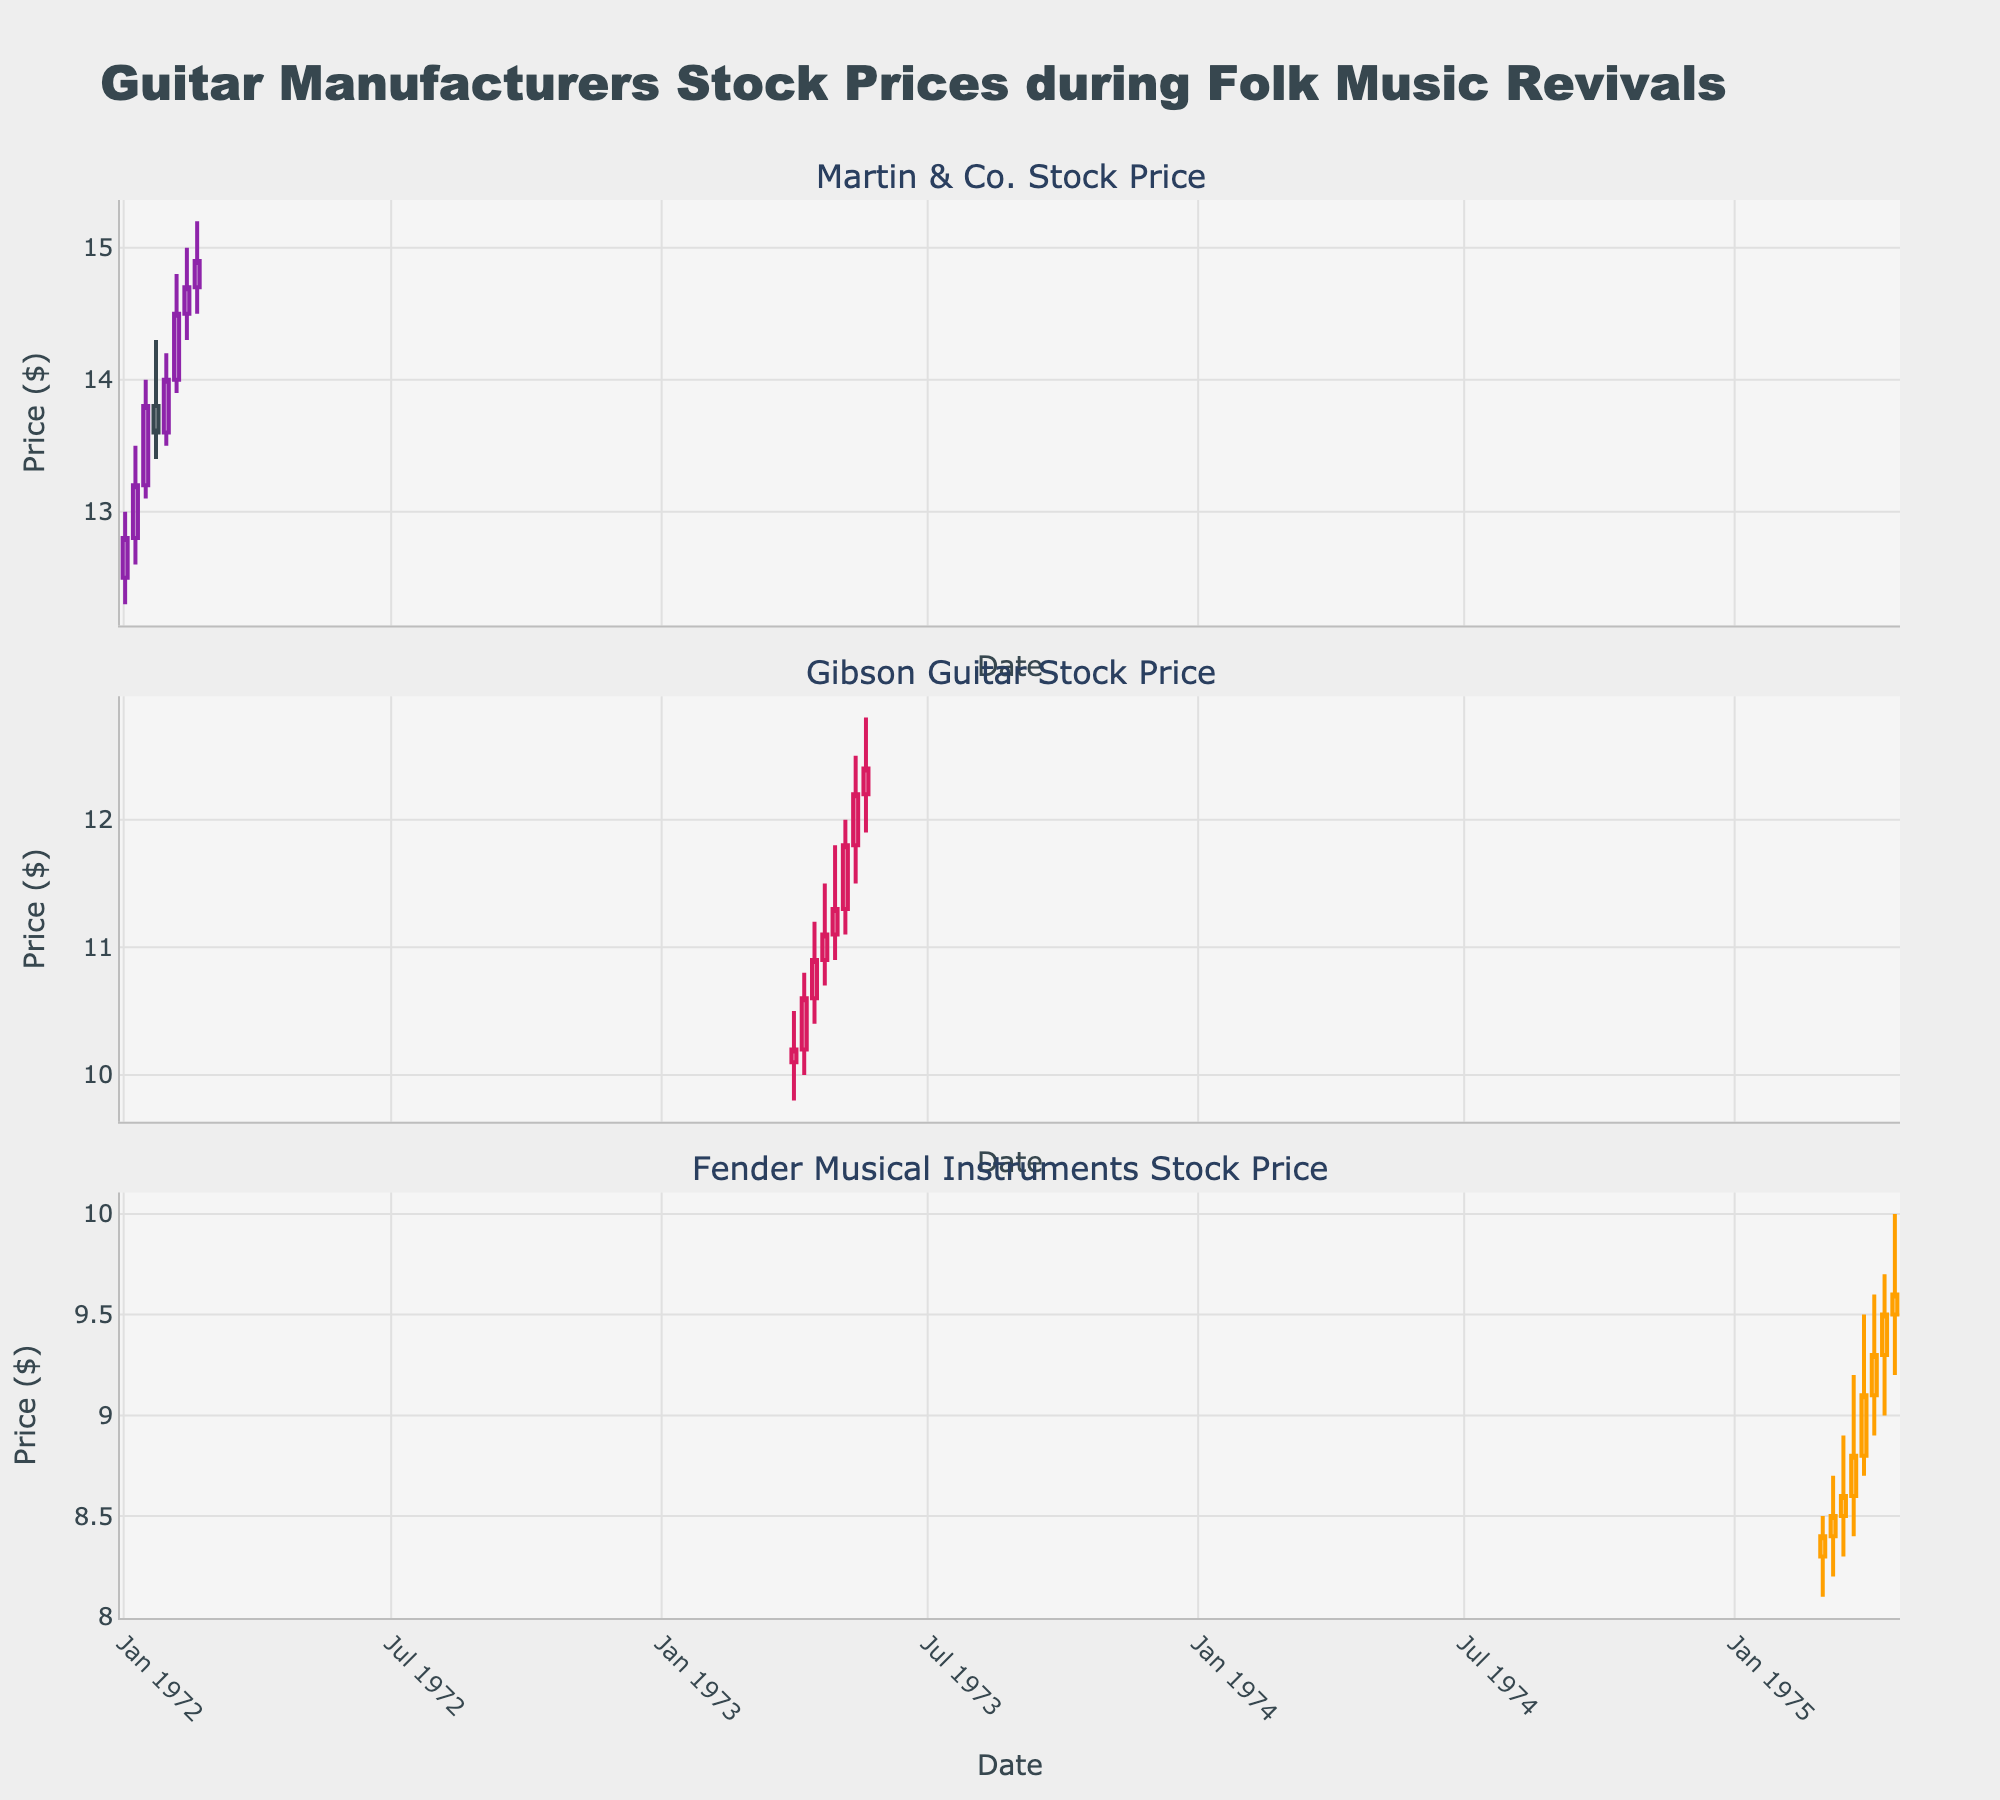What's the title of the plot? The title of the plot is shown at the top center of the figure in a larger, bold font in a different color which is easily visible.
Answer: Guitar Manufacturers Stock Prices during Folk Music Revivals Which company’s stock price is presented first in the plot? The company names appear as subplot titles, and the first company's name is the title of the first subplot at the top.
Answer: Martin & Co What was the highest closing price for Martin & Co., and when did it occur? By observing the highest points of the closing prices in the candlestick plot for Martin & Co., we can identify the week with the highest closing price. The date is shown at the bottom of each vertical candlestick.
Answer: $14.9 on 1972-02-20 During which date range did Fender Musical Instruments see a continuous increase in its closing price? Continuous increase in closing price can be identified as consecutive weeks where the closing price is higher than the previous week’s closing price. Look for this pattern in the plot for Fender Musical Instruments.
Answer: From 1975-03-02 to 1975-03-30 Compare the stock price trend of Gibson Guitar and Martin & Co.: Which company experienced a rapid increase and in which time period? By comparing the slope of the candlestick patterns for both companies, a rapid increase would show a steeper upward trend or consecutive tall bullish candlesticks.
Answer: Martin & Co. from 1972-01-02 to 1972-02-20 What was the price range (difference between high and low prices) for Gibson Guitar during the week of 1973-04-15? Find the candlestick for the specified week and calculate the difference between the high and low prices shown on the plot.
Answer: $0.8 (11.2 - 10.4) Which company experienced the highest volatility in the given dataset? Volatility can be inferred from the fluctuations in price ranges shown in the candlesticks. Look for the company with the largest range between highs and lows over multiple weeks.
Answer: Martin & Co What's the general trend of the stock prices for Fender Musical Instruments during the provided time period? Observe the general slope of the candlesticks for the given time period to identify if the trend is upward, downward, or stable.
Answer: Upward trend 